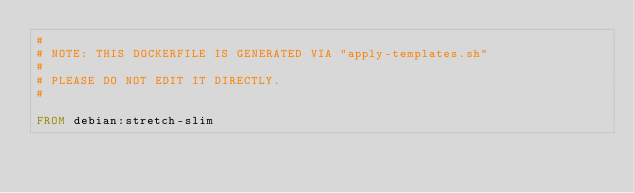Convert code to text. <code><loc_0><loc_0><loc_500><loc_500><_Dockerfile_>#
# NOTE: THIS DOCKERFILE IS GENERATED VIA "apply-templates.sh"
#
# PLEASE DO NOT EDIT IT DIRECTLY.
#

FROM debian:stretch-slim
</code> 